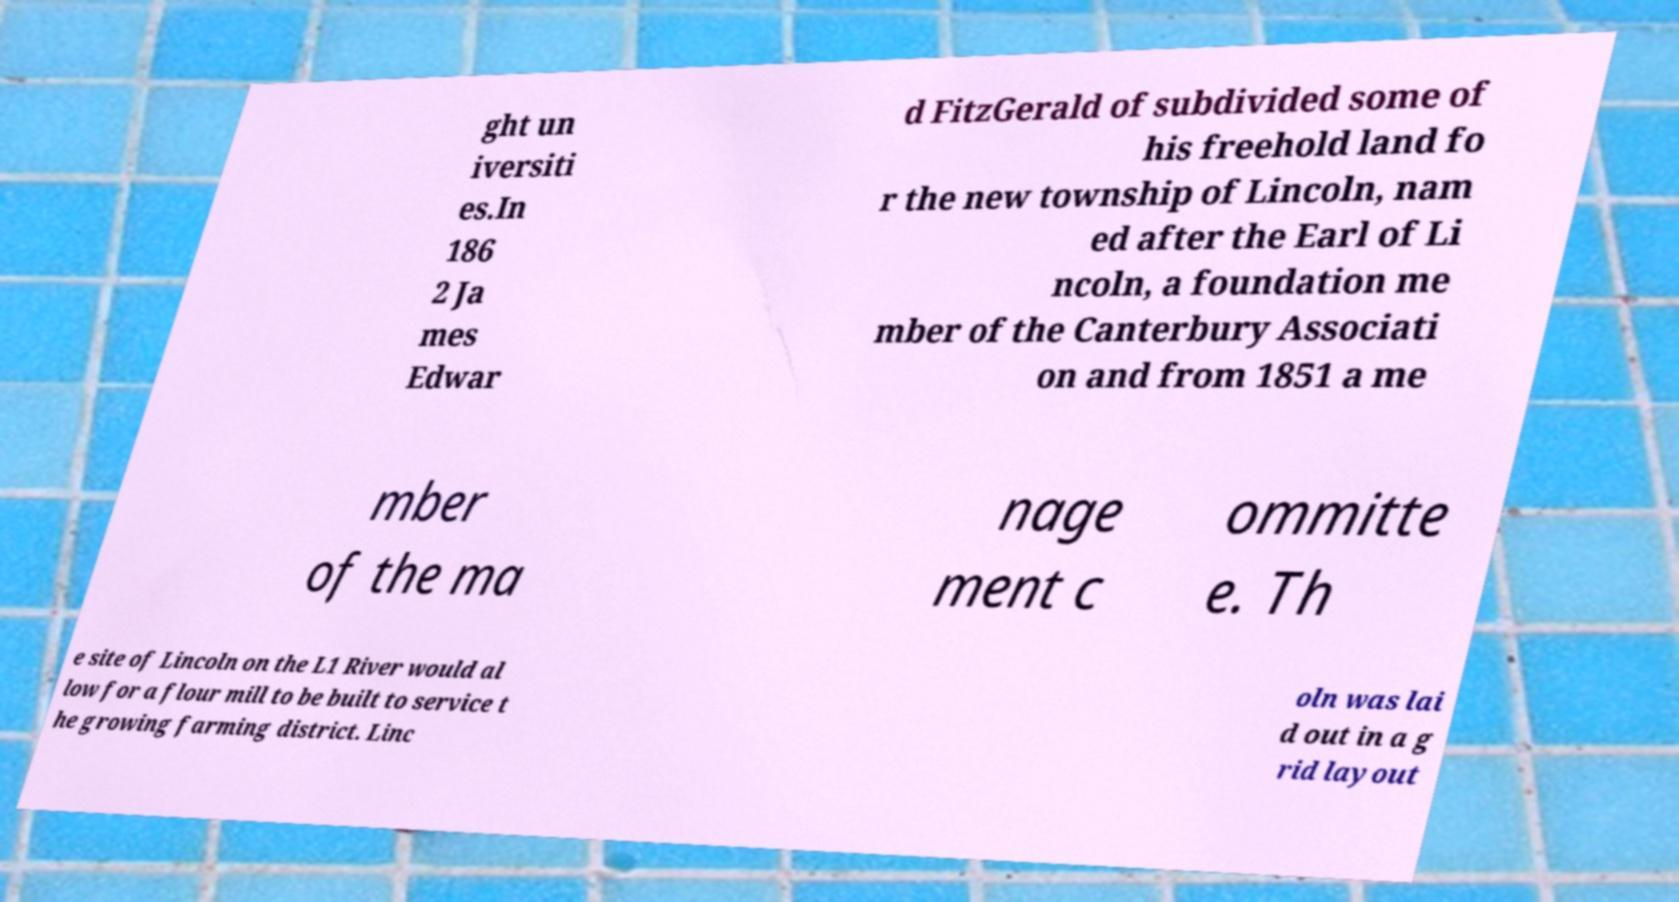Please identify and transcribe the text found in this image. ght un iversiti es.In 186 2 Ja mes Edwar d FitzGerald of subdivided some of his freehold land fo r the new township of Lincoln, nam ed after the Earl of Li ncoln, a foundation me mber of the Canterbury Associati on and from 1851 a me mber of the ma nage ment c ommitte e. Th e site of Lincoln on the L1 River would al low for a flour mill to be built to service t he growing farming district. Linc oln was lai d out in a g rid layout 